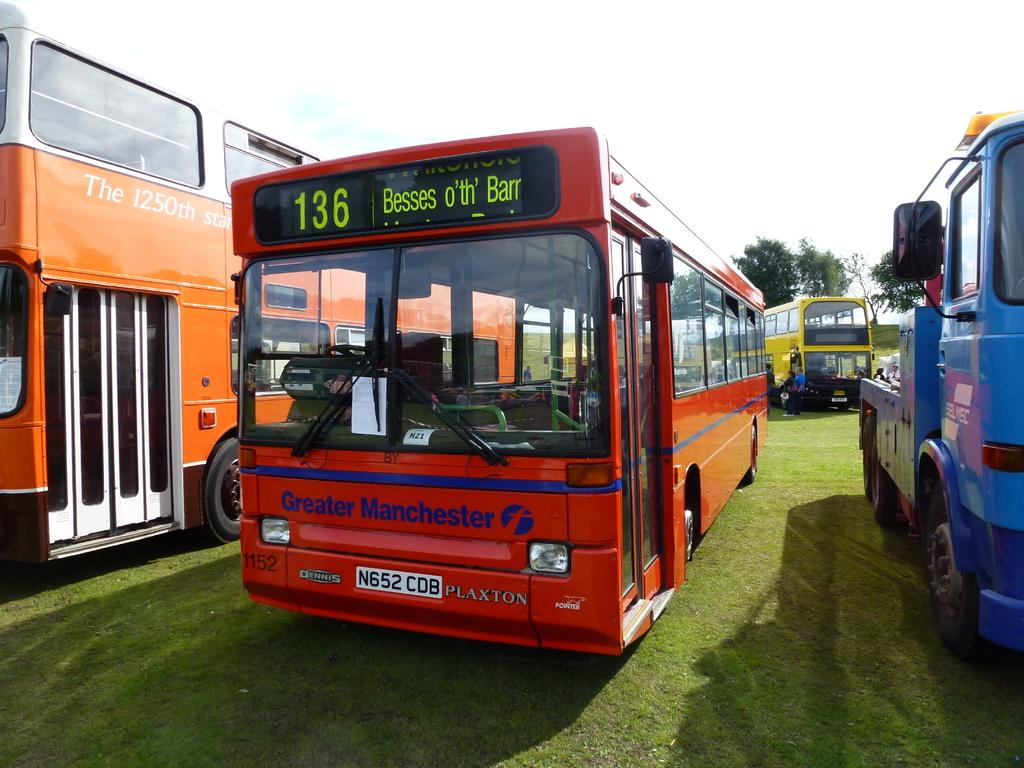What type of vehicles can be seen in the image? There are buses in the image. What are the people in the image doing? The people in the image are standing. What can be seen in the background of the image? There are trees in the background of the image. What type of soap is being used to clean the lamp in the image? There is no soap or lamp present in the image. 